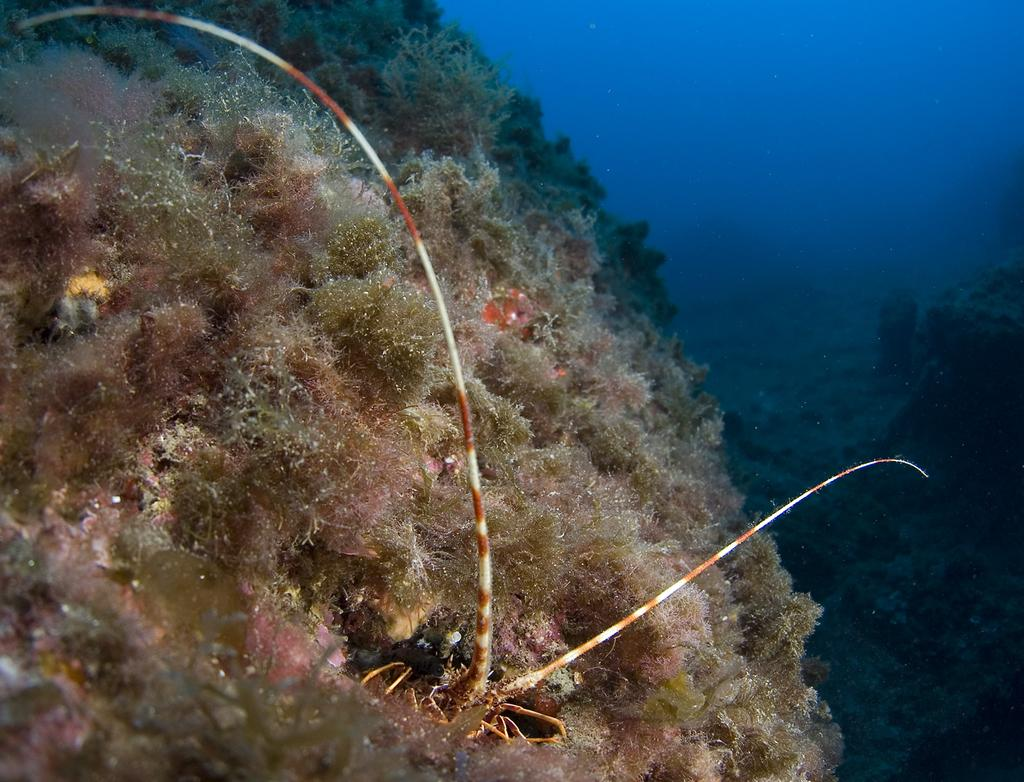What is the primary subject of the image? The image shows an inside view of water. Are there any living organisms or objects visible in the water? Yes, there are plants visible in the water. What can be seen at the bottom of the image? There is an object at the bottom of the image. What type of government is depicted in the image? There is no government depicted in the image; it shows an inside view of water with plants and an object at the bottom. How does the jelly interact with the plants in the image? There is no jelly present in the image; it features an inside view of water with plants and an object at the bottom. 